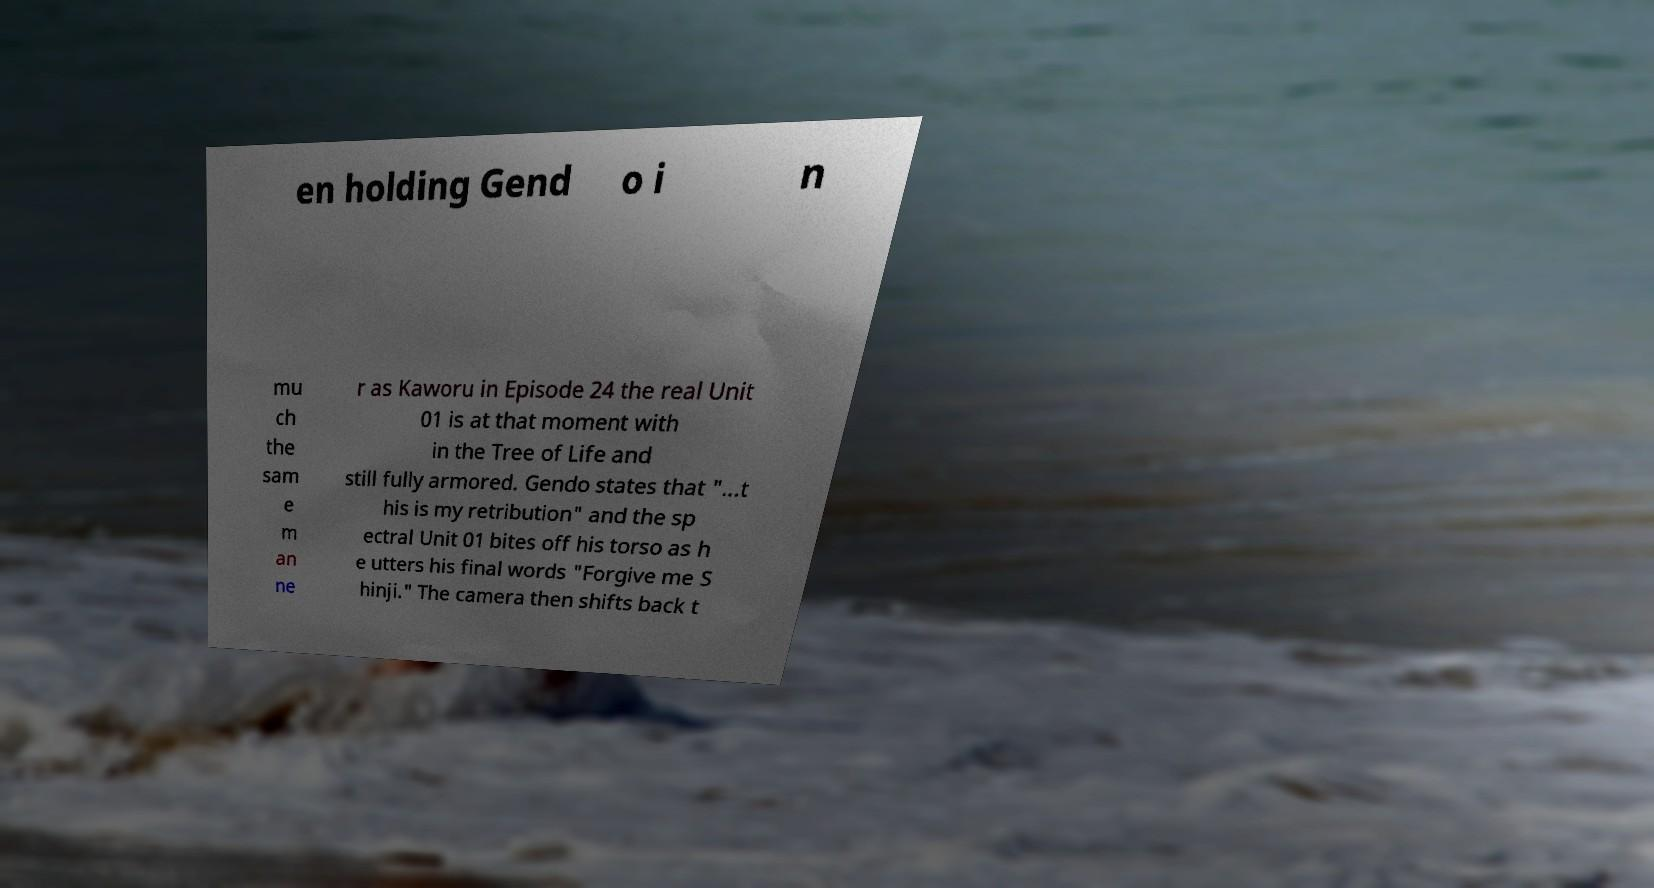I need the written content from this picture converted into text. Can you do that? en holding Gend o i n mu ch the sam e m an ne r as Kaworu in Episode 24 the real Unit 01 is at that moment with in the Tree of Life and still fully armored. Gendo states that "...t his is my retribution" and the sp ectral Unit 01 bites off his torso as h e utters his final words "Forgive me S hinji." The camera then shifts back t 